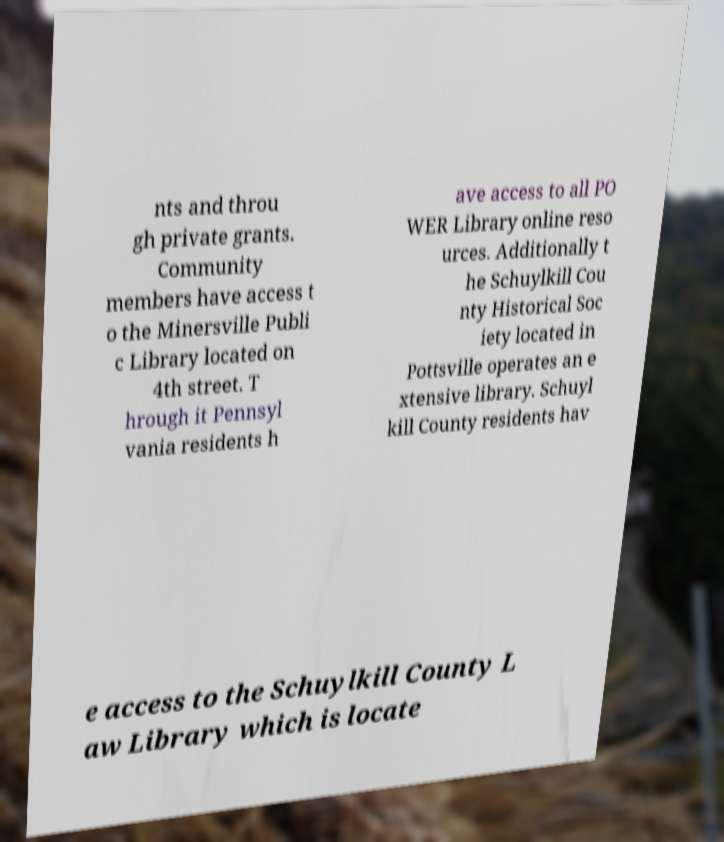Could you extract and type out the text from this image? nts and throu gh private grants. Community members have access t o the Minersville Publi c Library located on 4th street. T hrough it Pennsyl vania residents h ave access to all PO WER Library online reso urces. Additionally t he Schuylkill Cou nty Historical Soc iety located in Pottsville operates an e xtensive library. Schuyl kill County residents hav e access to the Schuylkill County L aw Library which is locate 